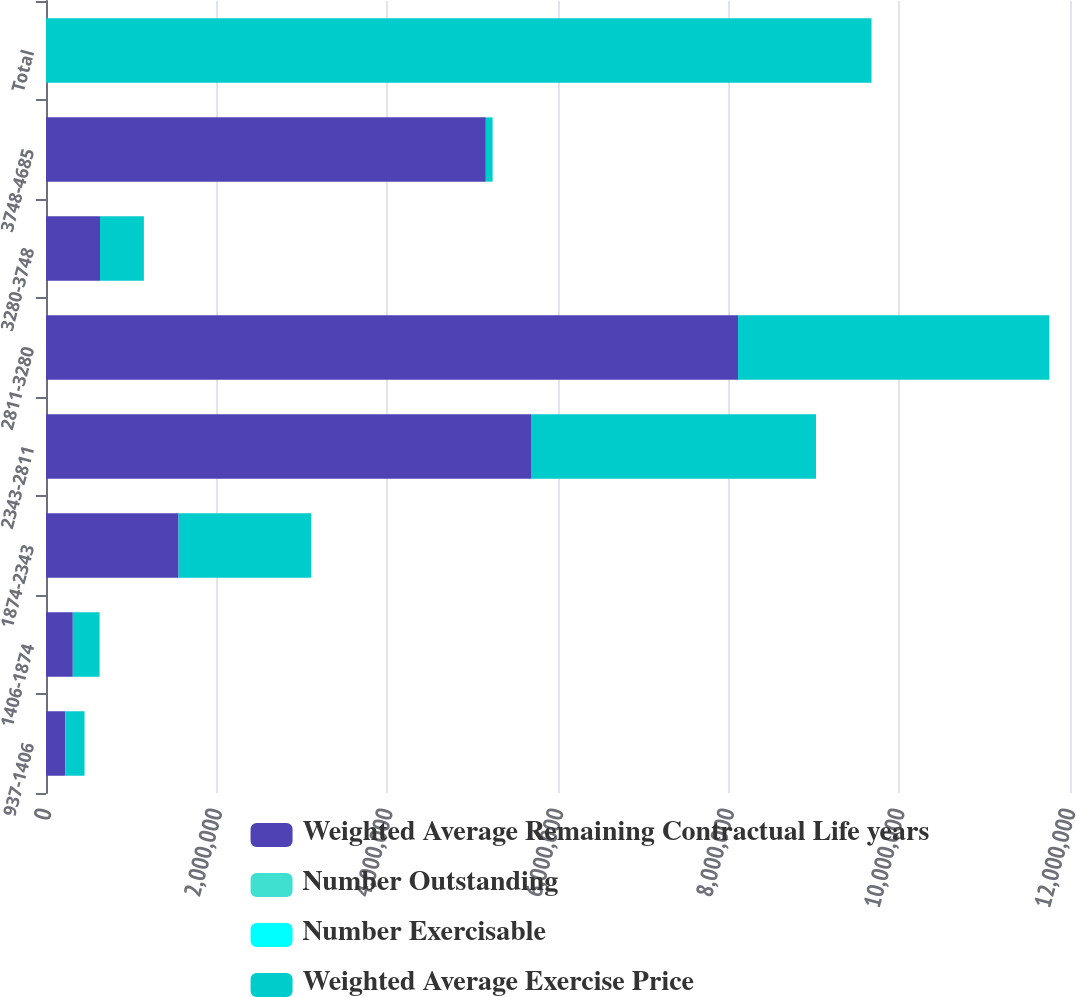<chart> <loc_0><loc_0><loc_500><loc_500><stacked_bar_chart><ecel><fcel>937-1406<fcel>1406-1874<fcel>1874-2343<fcel>2343-2811<fcel>2811-3280<fcel>3280-3748<fcel>3748-4685<fcel>Total<nl><fcel>Weighted Average Remaining Contractual Life years<fcel>225747<fcel>313946<fcel>1.55382e+06<fcel>5.68369e+06<fcel>8.10994e+06<fcel>632875<fcel>5.15425e+06<fcel>42.89<nl><fcel>Number Outstanding<fcel>1.4<fcel>3.8<fcel>3.3<fcel>6.4<fcel>6.9<fcel>5.7<fcel>9<fcel>6.9<nl><fcel>Number Exercisable<fcel>11.82<fcel>18.28<fcel>19.58<fcel>24.4<fcel>31.68<fcel>33.85<fcel>42.89<fcel>31.23<nl><fcel>Weighted Average Exercise Price<fcel>225747<fcel>313946<fcel>1.55382e+06<fcel>3.33949e+06<fcel>3.64775e+06<fcel>514075<fcel>79150<fcel>9.67399e+06<nl></chart> 